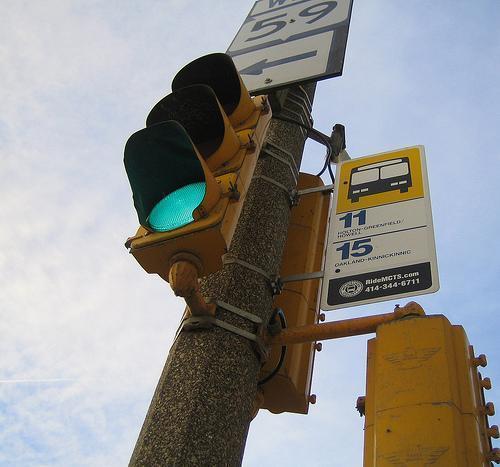How many traffic signals?
Give a very brief answer. 3. How many signs?
Give a very brief answer. 2. 